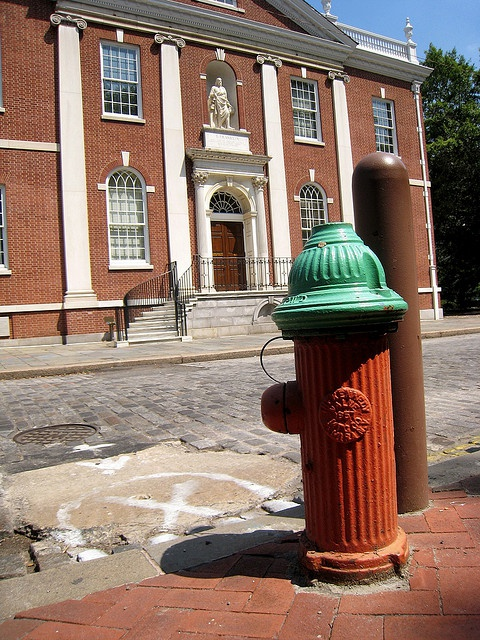Describe the objects in this image and their specific colors. I can see a fire hydrant in black, maroon, brown, and red tones in this image. 